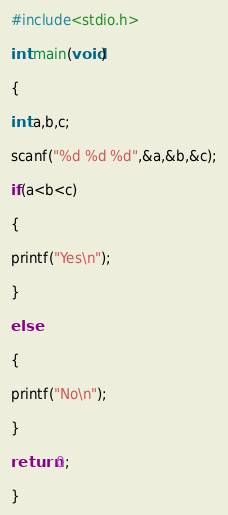Convert code to text. <code><loc_0><loc_0><loc_500><loc_500><_C_>#include<stdio.h>

int main(void)

{

int a,b,c;

scanf("%d %d %d",&a,&b,&c);

if(a<b<c)

{

printf("Yes\n");

}

else

{

printf("No\n");

}

return 0;

}</code> 